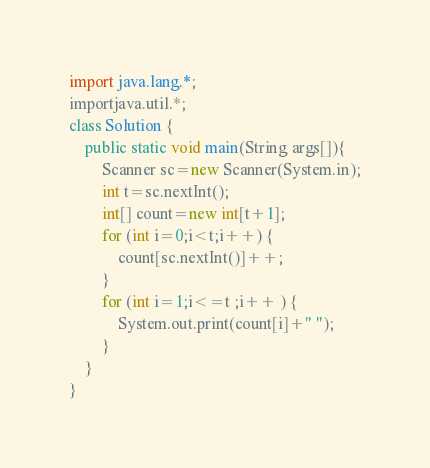Convert code to text. <code><loc_0><loc_0><loc_500><loc_500><_Java_>import java.lang.*;
importjava.util.*;
class Solution {
	public static void main(String args[]){
		Scanner sc=new Scanner(System.in);
		int t=sc.nextInt();
		int[] count=new int[t+1];
		for (int i=0;i<t;i++) {
			count[sc.nextInt()]++;
		}
		for (int i=1;i<=t ;i++ ) {
			System.out.print(count[i]+" ");
		}
	}
}</code> 